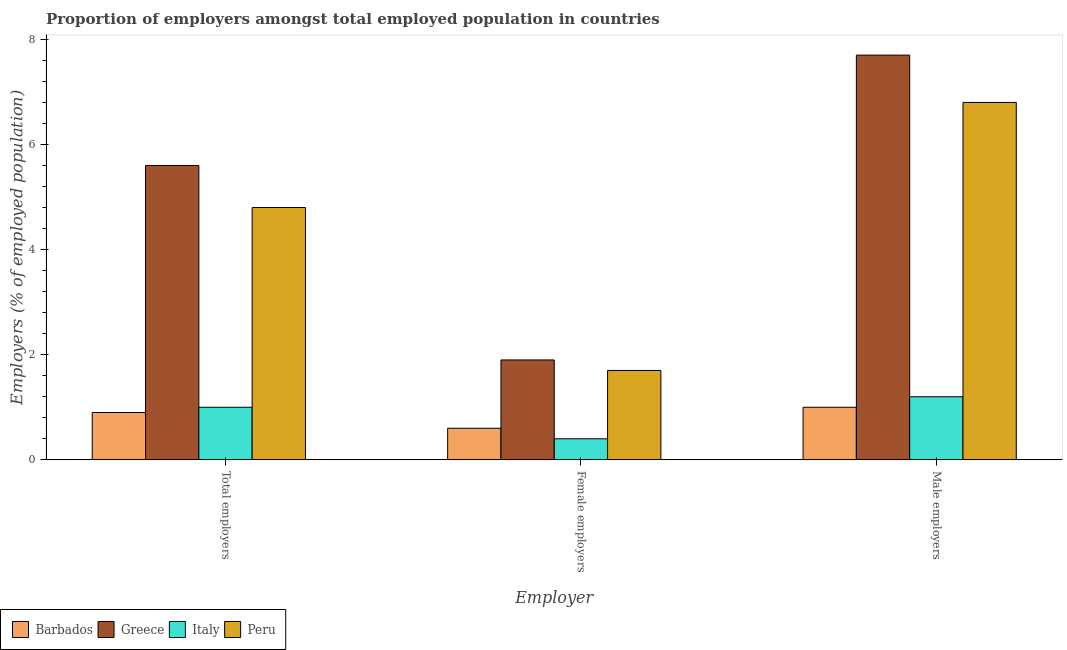How many groups of bars are there?
Give a very brief answer. 3. Are the number of bars on each tick of the X-axis equal?
Your response must be concise. Yes. How many bars are there on the 1st tick from the left?
Ensure brevity in your answer.  4. What is the label of the 3rd group of bars from the left?
Provide a succinct answer. Male employers. What is the percentage of male employers in Greece?
Offer a very short reply. 7.7. Across all countries, what is the maximum percentage of female employers?
Offer a very short reply. 1.9. Across all countries, what is the minimum percentage of female employers?
Your answer should be compact. 0.4. In which country was the percentage of male employers minimum?
Give a very brief answer. Barbados. What is the total percentage of male employers in the graph?
Offer a terse response. 16.7. What is the difference between the percentage of male employers in Italy and that in Peru?
Give a very brief answer. -5.6. What is the difference between the percentage of total employers in Barbados and the percentage of female employers in Greece?
Your answer should be compact. -1. What is the average percentage of total employers per country?
Ensure brevity in your answer.  3.08. What is the difference between the percentage of female employers and percentage of total employers in Barbados?
Your answer should be very brief. -0.3. What is the ratio of the percentage of total employers in Italy to that in Barbados?
Offer a very short reply. 1.11. Is the percentage of female employers in Italy less than that in Greece?
Provide a short and direct response. Yes. Is the difference between the percentage of total employers in Greece and Italy greater than the difference between the percentage of male employers in Greece and Italy?
Your response must be concise. No. What is the difference between the highest and the second highest percentage of female employers?
Keep it short and to the point. 0.2. What is the difference between the highest and the lowest percentage of female employers?
Ensure brevity in your answer.  1.5. What does the 1st bar from the right in Male employers represents?
Provide a succinct answer. Peru. How many countries are there in the graph?
Give a very brief answer. 4. What is the difference between two consecutive major ticks on the Y-axis?
Provide a succinct answer. 2. Does the graph contain any zero values?
Offer a very short reply. No. How many legend labels are there?
Your answer should be very brief. 4. How are the legend labels stacked?
Your answer should be very brief. Horizontal. What is the title of the graph?
Offer a terse response. Proportion of employers amongst total employed population in countries. Does "Micronesia" appear as one of the legend labels in the graph?
Provide a short and direct response. No. What is the label or title of the X-axis?
Provide a short and direct response. Employer. What is the label or title of the Y-axis?
Your answer should be compact. Employers (% of employed population). What is the Employers (% of employed population) of Barbados in Total employers?
Provide a short and direct response. 0.9. What is the Employers (% of employed population) in Greece in Total employers?
Give a very brief answer. 5.6. What is the Employers (% of employed population) of Peru in Total employers?
Your answer should be compact. 4.8. What is the Employers (% of employed population) of Barbados in Female employers?
Offer a terse response. 0.6. What is the Employers (% of employed population) of Greece in Female employers?
Give a very brief answer. 1.9. What is the Employers (% of employed population) of Italy in Female employers?
Offer a terse response. 0.4. What is the Employers (% of employed population) in Peru in Female employers?
Keep it short and to the point. 1.7. What is the Employers (% of employed population) of Barbados in Male employers?
Your response must be concise. 1. What is the Employers (% of employed population) in Greece in Male employers?
Your answer should be compact. 7.7. What is the Employers (% of employed population) of Italy in Male employers?
Give a very brief answer. 1.2. What is the Employers (% of employed population) of Peru in Male employers?
Keep it short and to the point. 6.8. Across all Employer, what is the maximum Employers (% of employed population) of Greece?
Ensure brevity in your answer.  7.7. Across all Employer, what is the maximum Employers (% of employed population) in Italy?
Ensure brevity in your answer.  1.2. Across all Employer, what is the maximum Employers (% of employed population) in Peru?
Your response must be concise. 6.8. Across all Employer, what is the minimum Employers (% of employed population) of Barbados?
Offer a very short reply. 0.6. Across all Employer, what is the minimum Employers (% of employed population) of Greece?
Your answer should be very brief. 1.9. Across all Employer, what is the minimum Employers (% of employed population) of Italy?
Offer a terse response. 0.4. Across all Employer, what is the minimum Employers (% of employed population) in Peru?
Your answer should be compact. 1.7. What is the total Employers (% of employed population) of Peru in the graph?
Provide a succinct answer. 13.3. What is the difference between the Employers (% of employed population) in Italy in Total employers and that in Female employers?
Offer a very short reply. 0.6. What is the difference between the Employers (% of employed population) of Peru in Total employers and that in Female employers?
Provide a short and direct response. 3.1. What is the difference between the Employers (% of employed population) of Italy in Total employers and that in Male employers?
Offer a very short reply. -0.2. What is the difference between the Employers (% of employed population) in Peru in Total employers and that in Male employers?
Ensure brevity in your answer.  -2. What is the difference between the Employers (% of employed population) in Barbados in Female employers and that in Male employers?
Provide a succinct answer. -0.4. What is the difference between the Employers (% of employed population) in Barbados in Total employers and the Employers (% of employed population) in Italy in Female employers?
Your answer should be very brief. 0.5. What is the difference between the Employers (% of employed population) in Barbados in Total employers and the Employers (% of employed population) in Peru in Female employers?
Your response must be concise. -0.8. What is the difference between the Employers (% of employed population) of Greece in Total employers and the Employers (% of employed population) of Peru in Female employers?
Offer a very short reply. 3.9. What is the difference between the Employers (% of employed population) in Greece in Total employers and the Employers (% of employed population) in Italy in Male employers?
Offer a terse response. 4.4. What is the difference between the Employers (% of employed population) in Greece in Total employers and the Employers (% of employed population) in Peru in Male employers?
Ensure brevity in your answer.  -1.2. What is the difference between the Employers (% of employed population) of Greece in Female employers and the Employers (% of employed population) of Italy in Male employers?
Offer a terse response. 0.7. What is the difference between the Employers (% of employed population) of Italy in Female employers and the Employers (% of employed population) of Peru in Male employers?
Your answer should be compact. -6.4. What is the average Employers (% of employed population) of Greece per Employer?
Ensure brevity in your answer.  5.07. What is the average Employers (% of employed population) of Italy per Employer?
Offer a terse response. 0.87. What is the average Employers (% of employed population) in Peru per Employer?
Offer a very short reply. 4.43. What is the difference between the Employers (% of employed population) in Barbados and Employers (% of employed population) in Greece in Total employers?
Provide a short and direct response. -4.7. What is the difference between the Employers (% of employed population) of Barbados and Employers (% of employed population) of Italy in Total employers?
Provide a short and direct response. -0.1. What is the difference between the Employers (% of employed population) in Greece and Employers (% of employed population) in Italy in Total employers?
Your answer should be compact. 4.6. What is the difference between the Employers (% of employed population) in Barbados and Employers (% of employed population) in Italy in Female employers?
Ensure brevity in your answer.  0.2. What is the difference between the Employers (% of employed population) of Greece and Employers (% of employed population) of Peru in Female employers?
Your answer should be compact. 0.2. What is the difference between the Employers (% of employed population) of Barbados and Employers (% of employed population) of Greece in Male employers?
Provide a short and direct response. -6.7. What is the difference between the Employers (% of employed population) of Barbados and Employers (% of employed population) of Italy in Male employers?
Offer a very short reply. -0.2. What is the difference between the Employers (% of employed population) of Greece and Employers (% of employed population) of Italy in Male employers?
Keep it short and to the point. 6.5. What is the difference between the Employers (% of employed population) of Italy and Employers (% of employed population) of Peru in Male employers?
Offer a very short reply. -5.6. What is the ratio of the Employers (% of employed population) in Greece in Total employers to that in Female employers?
Your answer should be very brief. 2.95. What is the ratio of the Employers (% of employed population) in Italy in Total employers to that in Female employers?
Provide a short and direct response. 2.5. What is the ratio of the Employers (% of employed population) in Peru in Total employers to that in Female employers?
Keep it short and to the point. 2.82. What is the ratio of the Employers (% of employed population) in Greece in Total employers to that in Male employers?
Provide a succinct answer. 0.73. What is the ratio of the Employers (% of employed population) in Peru in Total employers to that in Male employers?
Offer a terse response. 0.71. What is the ratio of the Employers (% of employed population) in Greece in Female employers to that in Male employers?
Provide a succinct answer. 0.25. What is the ratio of the Employers (% of employed population) in Italy in Female employers to that in Male employers?
Offer a very short reply. 0.33. What is the ratio of the Employers (% of employed population) of Peru in Female employers to that in Male employers?
Provide a succinct answer. 0.25. What is the difference between the highest and the second highest Employers (% of employed population) in Barbados?
Your answer should be compact. 0.1. What is the difference between the highest and the second highest Employers (% of employed population) in Italy?
Your answer should be compact. 0.2. What is the difference between the highest and the lowest Employers (% of employed population) in Greece?
Your answer should be compact. 5.8. What is the difference between the highest and the lowest Employers (% of employed population) of Italy?
Provide a succinct answer. 0.8. What is the difference between the highest and the lowest Employers (% of employed population) in Peru?
Give a very brief answer. 5.1. 